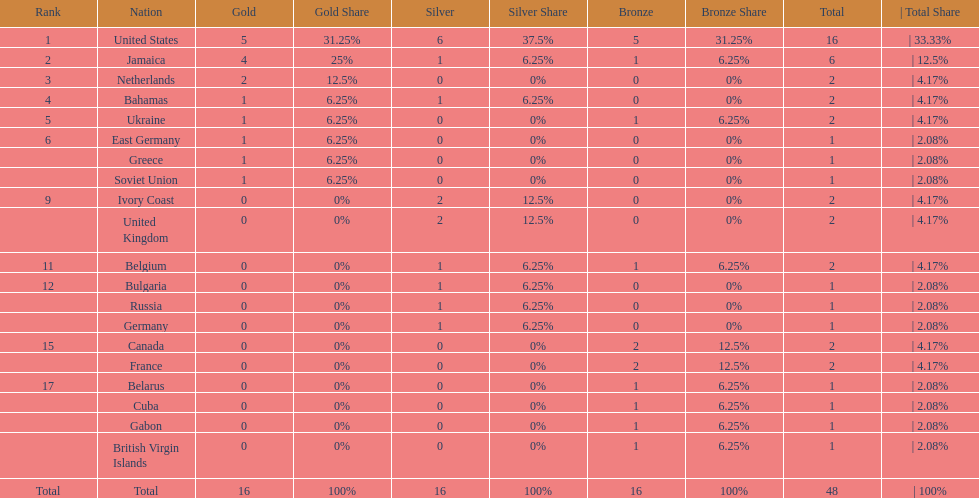How many nations won more than one silver medal? 3. 